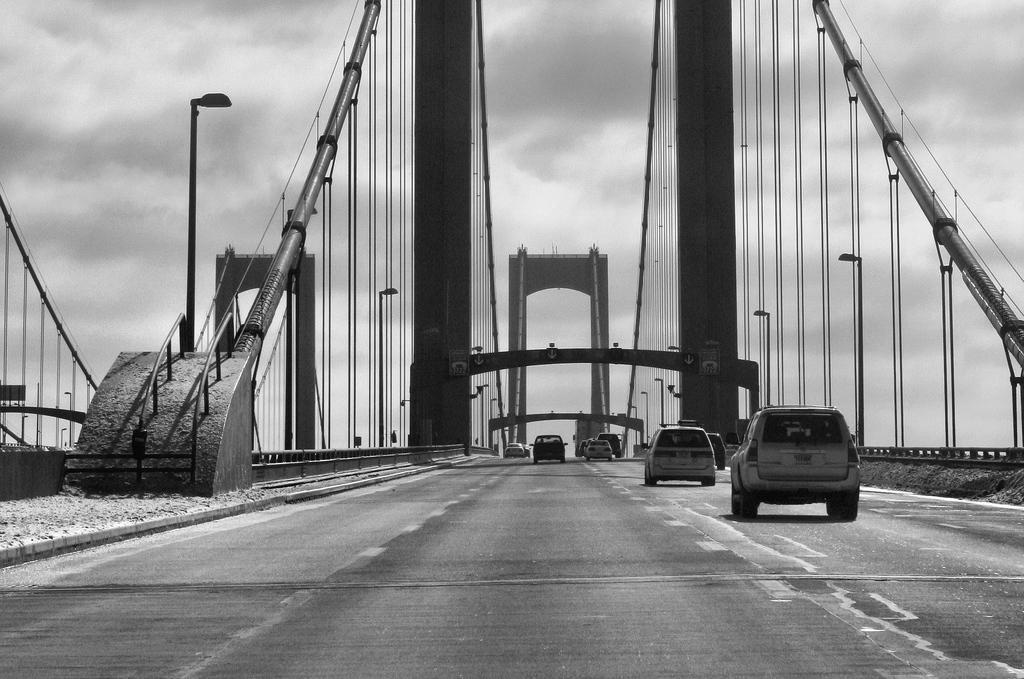Describe this image in one or two sentences. In the picture I can see vehicles on the road. In the background I can see street lights, wires, a bridge and the sky. This picture is black and white in color. 